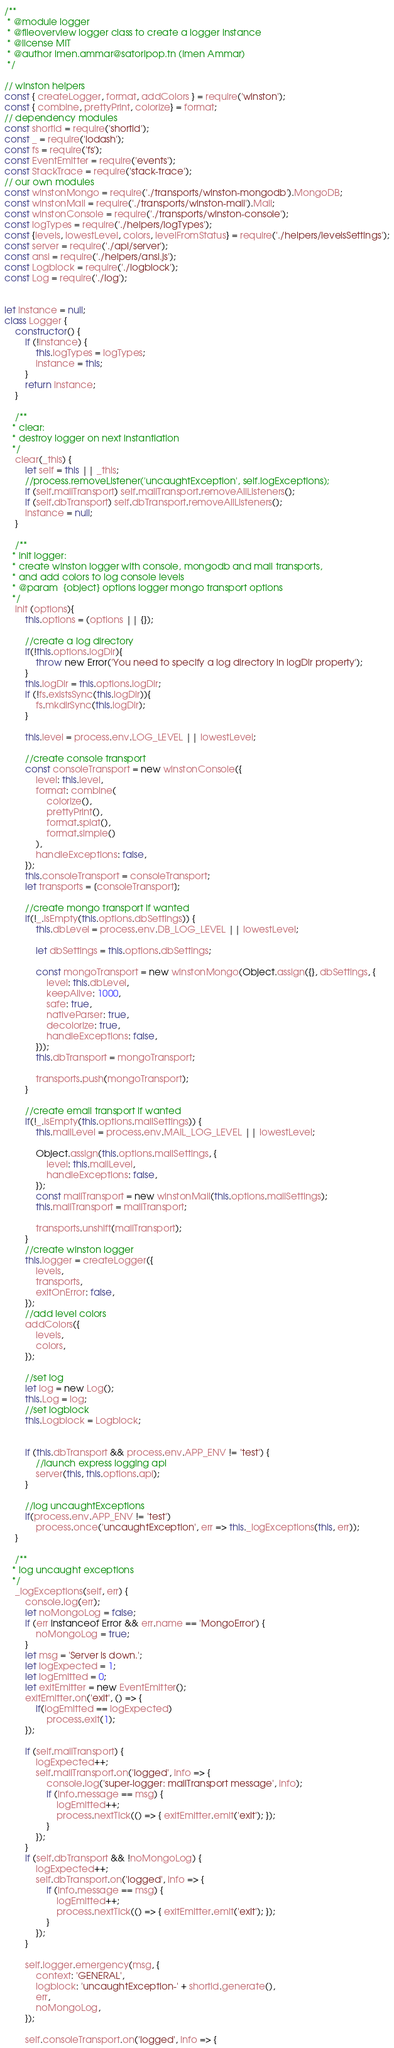<code> <loc_0><loc_0><loc_500><loc_500><_JavaScript_>/**
 * @module logger
 * @fileoverview logger class to create a logger instance
 * @license MIT
 * @author imen.ammar@satoripop.tn (Imen Ammar)
 */

// winston helpers
const { createLogger, format, addColors } = require('winston');
const { combine, prettyPrint, colorize} = format;
// dependency modules
const shortid = require('shortid');
const _ = require('lodash');
const fs = require('fs');
const EventEmitter = require('events');
const StackTrace = require('stack-trace');
// our own modules
const winstonMongo = require('./transports/winston-mongodb').MongoDB;
const winstonMail = require('./transports/winston-mail').Mail;
const winstonConsole = require('./transports/winston-console');
const logTypes = require('./helpers/logTypes');
const {levels, lowestLevel, colors, levelFromStatus} = require('./helpers/levelsSettings');
const server = require('./api/server');
const ansi = require('./helpers/ansi.js');
const Logblock = require('./logblock');
const Log = require('./log');


let instance = null;
class Logger {
	constructor() {
		if (!instance) {
			this.logTypes = logTypes;
			instance = this;
		}
		return instance;
	}

	/**
   * clear:
   * destroy logger on next instantiation
   */
	clear(_this) {
		let self = this || _this;
		//process.removeListener('uncaughtException', self.logExceptions);
		if (self.mailTransport) self.mailTransport.removeAllListeners();
		if (self.dbTransport) self.dbTransport.removeAllListeners();
		instance = null;
	}

	/**
   * init logger:
   * create winston logger with console, mongodb and mail transports,
   * and add colors to log console levels
   * @param  {object} options logger mongo transport options
   */
	init (options){
		this.options = (options || {});

		//create a log directory
		if(!this.options.logDir){
			throw new Error('You need to specify a log directory in logDir property');
		}
		this.logDir = this.options.logDir;
		if (!fs.existsSync(this.logDir)){
			fs.mkdirSync(this.logDir);
		}

		this.level = process.env.LOG_LEVEL || lowestLevel;

		//create console transport
		const consoleTransport = new winstonConsole({
			level: this.level,
			format: combine(
				colorize(),
				prettyPrint(),
				format.splat(),
				format.simple()
			),
			handleExceptions: false,
		});
		this.consoleTransport = consoleTransport;
		let transports = [consoleTransport];

		//create mongo transport if wanted
		if(!_.isEmpty(this.options.dbSettings)) {
			this.dbLevel = process.env.DB_LOG_LEVEL || lowestLevel;

			let dbSettings = this.options.dbSettings;

			const mongoTransport = new winstonMongo(Object.assign({}, dbSettings, {
				level: this.dbLevel,
				keepAlive: 1000,
				safe: true,
				nativeParser: true,
				decolorize: true,
				handleExceptions: false,
			}));
			this.dbTransport = mongoTransport;

			transports.push(mongoTransport);
		}

		//create email transport if wanted
		if(!_.isEmpty(this.options.mailSettings)) {
			this.mailLevel = process.env.MAIL_LOG_LEVEL || lowestLevel;

			Object.assign(this.options.mailSettings, {
				level: this.mailLevel,
				handleExceptions: false,
			});
			const mailTransport = new winstonMail(this.options.mailSettings);
			this.mailTransport = mailTransport;

			transports.unshift(mailTransport);
		}
		//create winston logger
		this.logger = createLogger({
			levels,
			transports,
			exitOnError: false,
		});
		//add level colors
		addColors({
			levels,
			colors,
		});

		//set log
		let log = new Log();
		this.Log = log;
		//set logblock
		this.Logblock = Logblock;


		if (this.dbTransport && process.env.APP_ENV != 'test') {
			//launch express logging api
			server(this, this.options.api);
		}

		//log uncaughtExceptions
		if(process.env.APP_ENV != 'test')
			process.once('uncaughtException', err => this._logExceptions(this, err));
	}

	/**
   * log uncaught exceptions
   */
	_logExceptions(self, err) {
		console.log(err);
		let noMongoLog = false;
		if (err instanceof Error && err.name == 'MongoError') {
			noMongoLog = true;
		}
		let msg = 'Server is down.';
		let logExpected = 1;
		let logEmitted = 0;
		let exitEmitter = new EventEmitter();
		exitEmitter.on('exit', () => {
			if(logEmitted == logExpected)
				process.exit(1);
		});

		if (self.mailTransport) {
			logExpected++;
			self.mailTransport.on('logged', info => {
				console.log('super-logger: mailTransport message', info);
				if (info.message == msg) {
					logEmitted++;
					process.nextTick(() => { exitEmitter.emit('exit'); });
				}
			});
		}
		if (self.dbTransport && !noMongoLog) {
			logExpected++;
			self.dbTransport.on('logged', info => {
				if (info.message == msg) {
					logEmitted++;
					process.nextTick(() => { exitEmitter.emit('exit'); });
				}
			});
		}

		self.logger.emergency(msg, {
			context: 'GENERAL',
			logblock: 'uncaughtException-' + shortid.generate(),
			err,
			noMongoLog,
		});

		self.consoleTransport.on('logged', info => {</code> 